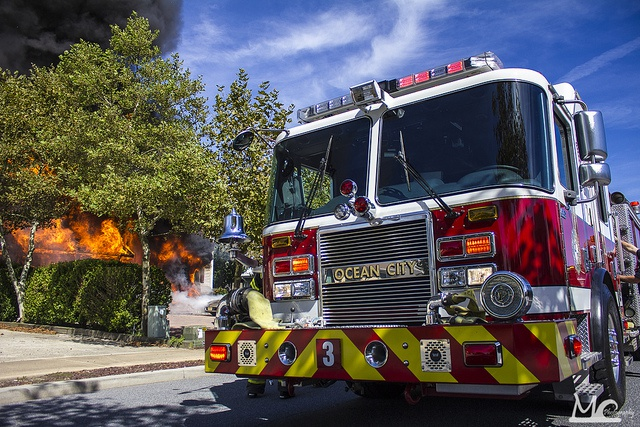Describe the objects in this image and their specific colors. I can see a truck in black, gray, maroon, and lightgray tones in this image. 